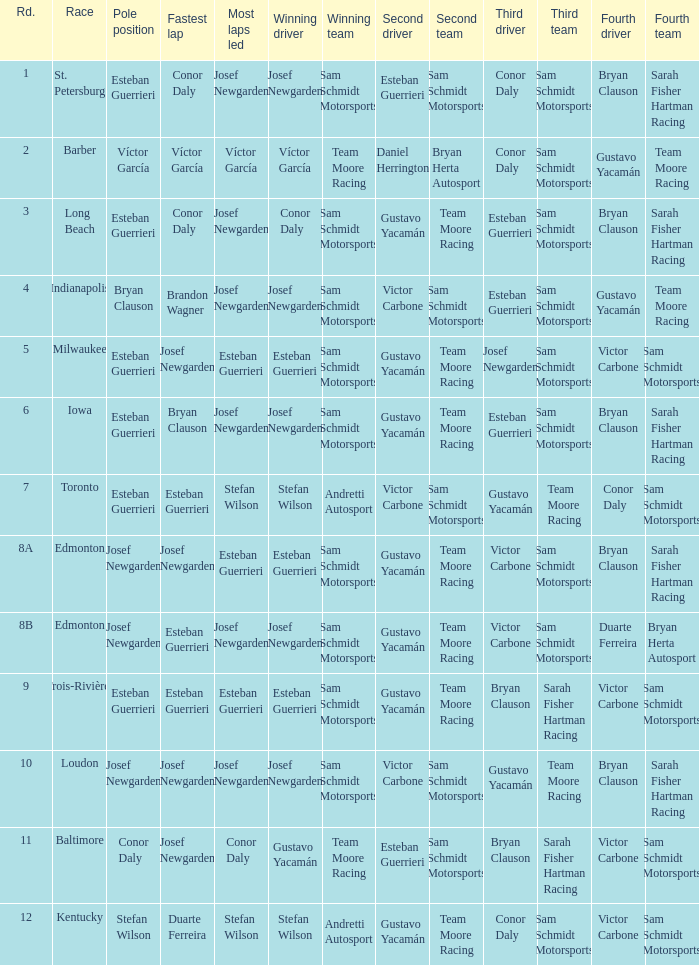Who had the fastest lap(s) when josef newgarden led the most laps at edmonton? Esteban Guerrieri. 